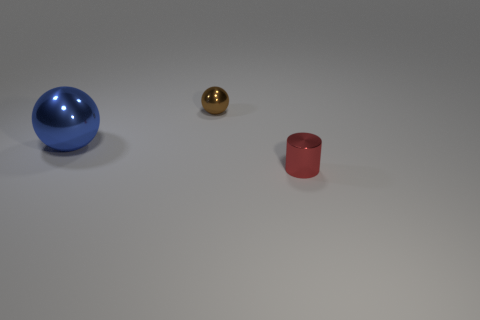Add 1 big green rubber spheres. How many objects exist? 4 Subtract all cylinders. How many objects are left? 2 Add 3 tiny cylinders. How many tiny cylinders exist? 4 Subtract 0 green cylinders. How many objects are left? 3 Subtract all small objects. Subtract all small purple metallic objects. How many objects are left? 1 Add 2 brown shiny things. How many brown shiny things are left? 3 